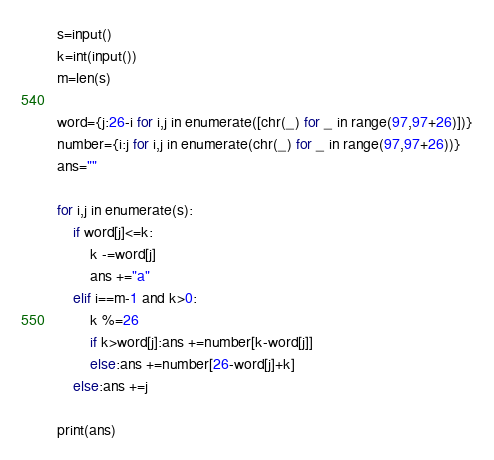Convert code to text. <code><loc_0><loc_0><loc_500><loc_500><_Python_>s=input()
k=int(input())
m=len(s)

word={j:26-i for i,j in enumerate([chr(_) for _ in range(97,97+26)])}
number={i:j for i,j in enumerate(chr(_) for _ in range(97,97+26))}
ans=""

for i,j in enumerate(s):
    if word[j]<=k:
        k -=word[j]
        ans +="a"
    elif i==m-1 and k>0:
        k %=26
        if k>word[j]:ans +=number[k-word[j]]
        else:ans +=number[26-word[j]+k]
    else:ans +=j

print(ans)</code> 